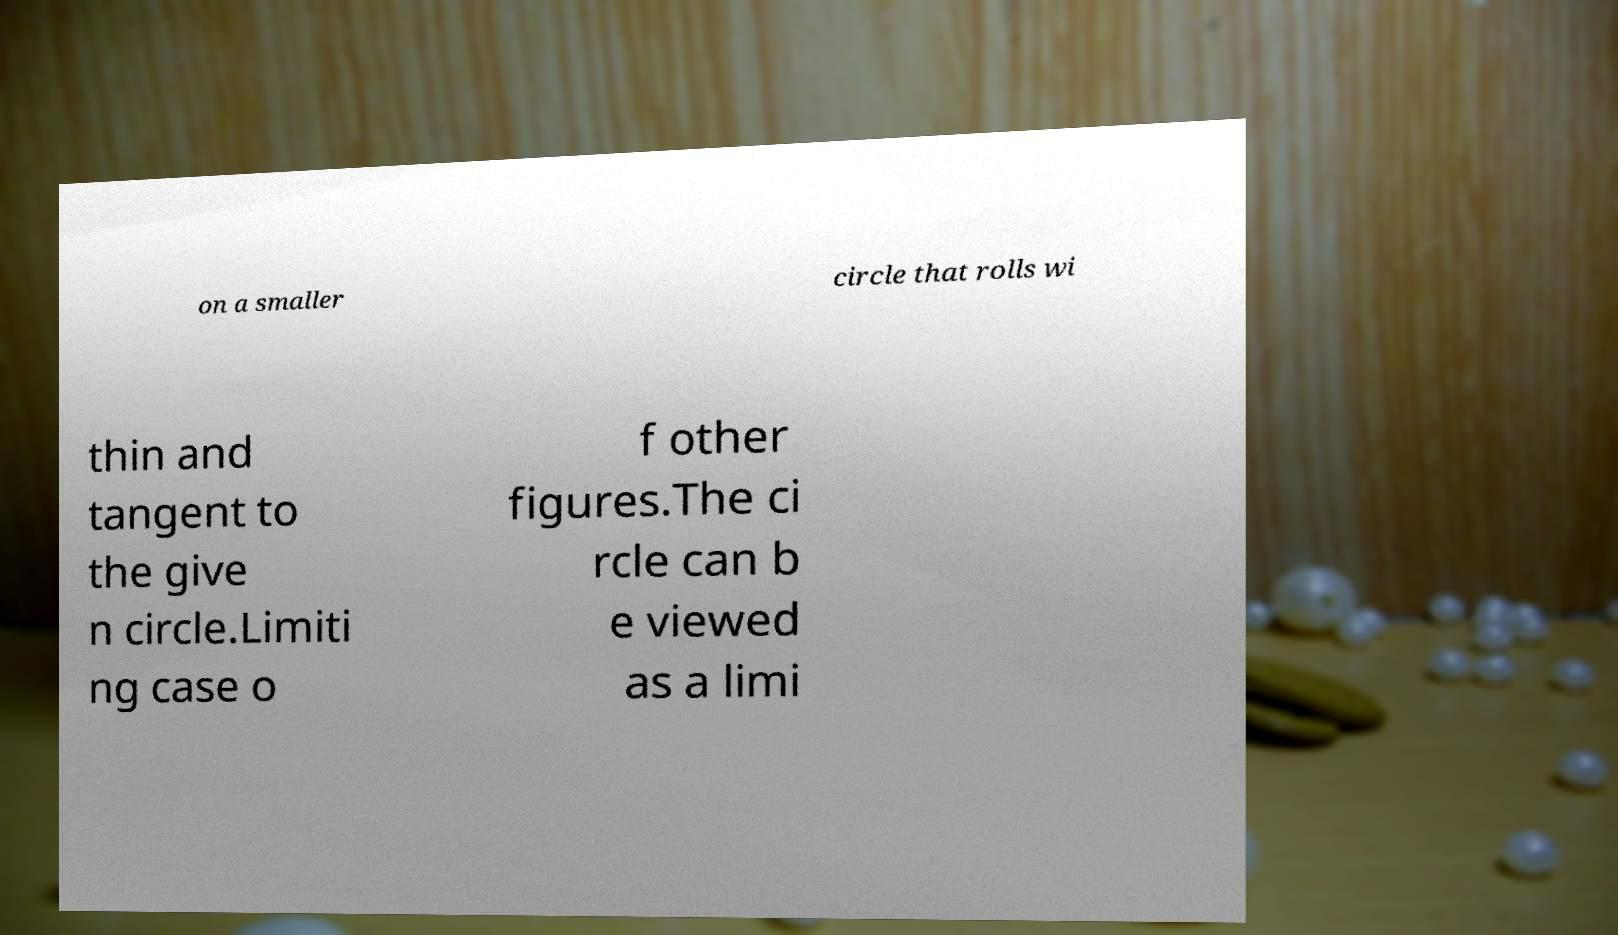Could you assist in decoding the text presented in this image and type it out clearly? on a smaller circle that rolls wi thin and tangent to the give n circle.Limiti ng case o f other figures.The ci rcle can b e viewed as a limi 